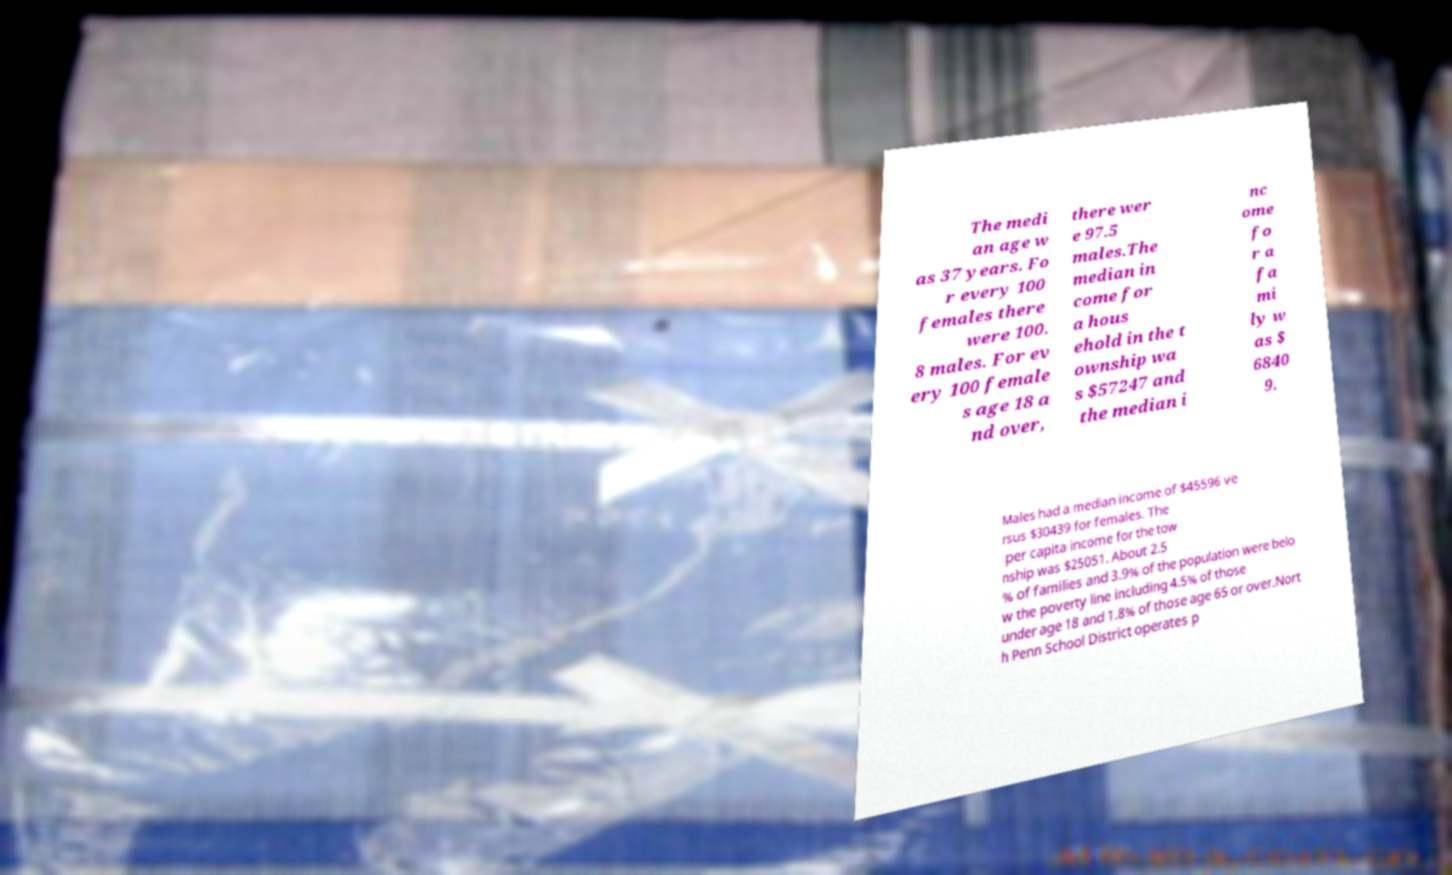Could you extract and type out the text from this image? The medi an age w as 37 years. Fo r every 100 females there were 100. 8 males. For ev ery 100 female s age 18 a nd over, there wer e 97.5 males.The median in come for a hous ehold in the t ownship wa s $57247 and the median i nc ome fo r a fa mi ly w as $ 6840 9. Males had a median income of $45596 ve rsus $30439 for females. The per capita income for the tow nship was $25051. About 2.5 % of families and 3.9% of the population were belo w the poverty line including 4.5% of those under age 18 and 1.8% of those age 65 or over.Nort h Penn School District operates p 